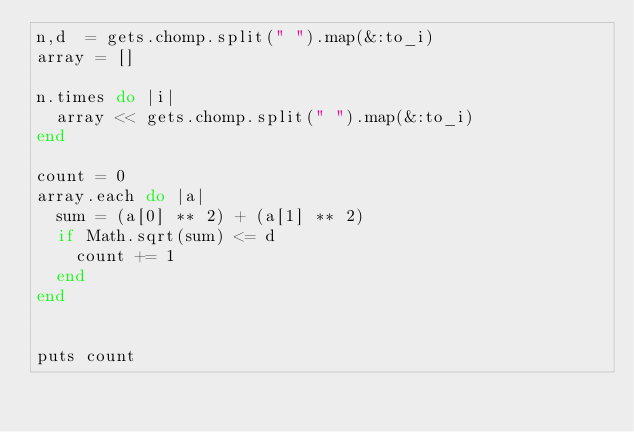Convert code to text. <code><loc_0><loc_0><loc_500><loc_500><_Ruby_>n,d  = gets.chomp.split(" ").map(&:to_i)
array = []

n.times do |i|
  array << gets.chomp.split(" ").map(&:to_i)
end

count = 0
array.each do |a|
  sum = (a[0] ** 2) + (a[1] ** 2)
  if Math.sqrt(sum) <= d
    count += 1
  end
end


puts count
</code> 